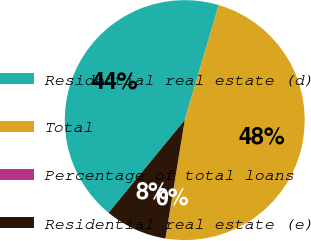<chart> <loc_0><loc_0><loc_500><loc_500><pie_chart><fcel>Residential real estate (d)<fcel>Total<fcel>Percentage of total loans<fcel>Residential real estate (e)<nl><fcel>43.63%<fcel>47.99%<fcel>0.02%<fcel>8.37%<nl></chart> 